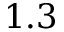Convert formula to latex. <formula><loc_0><loc_0><loc_500><loc_500>1 . 3</formula> 